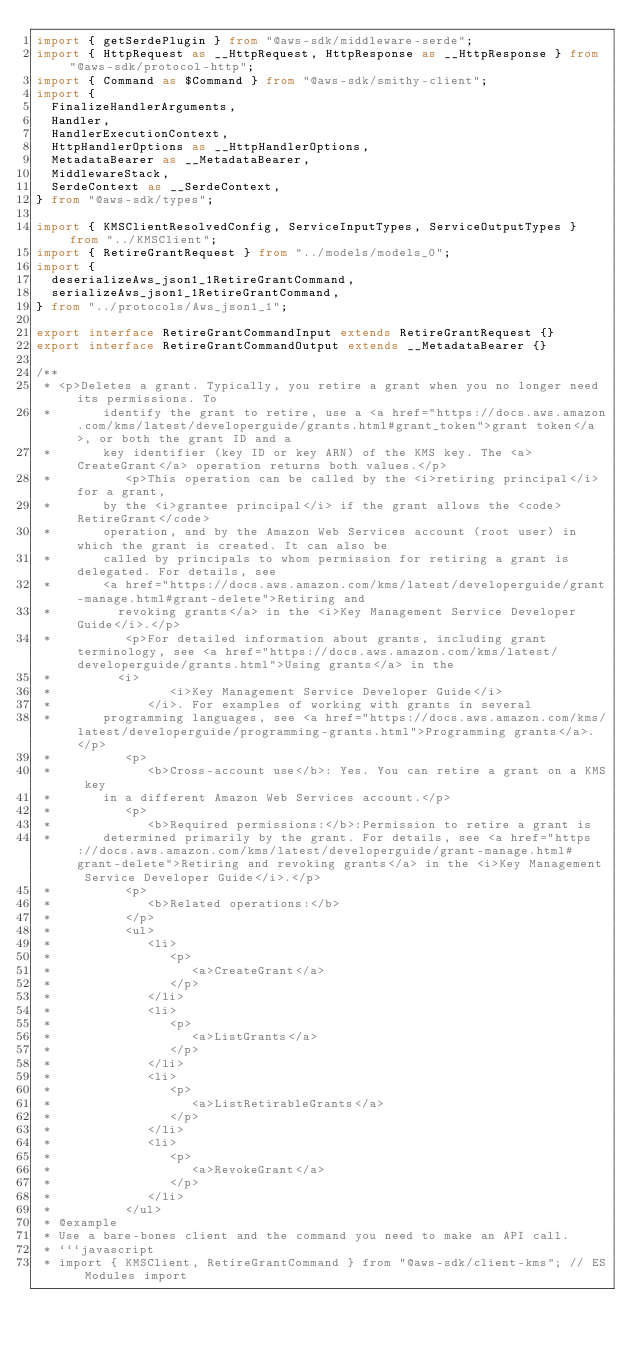Convert code to text. <code><loc_0><loc_0><loc_500><loc_500><_TypeScript_>import { getSerdePlugin } from "@aws-sdk/middleware-serde";
import { HttpRequest as __HttpRequest, HttpResponse as __HttpResponse } from "@aws-sdk/protocol-http";
import { Command as $Command } from "@aws-sdk/smithy-client";
import {
  FinalizeHandlerArguments,
  Handler,
  HandlerExecutionContext,
  HttpHandlerOptions as __HttpHandlerOptions,
  MetadataBearer as __MetadataBearer,
  MiddlewareStack,
  SerdeContext as __SerdeContext,
} from "@aws-sdk/types";

import { KMSClientResolvedConfig, ServiceInputTypes, ServiceOutputTypes } from "../KMSClient";
import { RetireGrantRequest } from "../models/models_0";
import {
  deserializeAws_json1_1RetireGrantCommand,
  serializeAws_json1_1RetireGrantCommand,
} from "../protocols/Aws_json1_1";

export interface RetireGrantCommandInput extends RetireGrantRequest {}
export interface RetireGrantCommandOutput extends __MetadataBearer {}

/**
 * <p>Deletes a grant. Typically, you retire a grant when you no longer need its permissions. To
 *       identify the grant to retire, use a <a href="https://docs.aws.amazon.com/kms/latest/developerguide/grants.html#grant_token">grant token</a>, or both the grant ID and a
 *       key identifier (key ID or key ARN) of the KMS key. The <a>CreateGrant</a> operation returns both values.</p>
 *          <p>This operation can be called by the <i>retiring principal</i> for a grant,
 *       by the <i>grantee principal</i> if the grant allows the <code>RetireGrant</code>
 *       operation, and by the Amazon Web Services account (root user) in which the grant is created. It can also be
 *       called by principals to whom permission for retiring a grant is delegated. For details, see
 *       <a href="https://docs.aws.amazon.com/kms/latest/developerguide/grant-manage.html#grant-delete">Retiring and
 *         revoking grants</a> in the <i>Key Management Service Developer Guide</i>.</p>
 *          <p>For detailed information about grants, including grant terminology, see <a href="https://docs.aws.amazon.com/kms/latest/developerguide/grants.html">Using grants</a> in the
 *         <i>
 *                <i>Key Management Service Developer Guide</i>
 *             </i>. For examples of working with grants in several
 *       programming languages, see <a href="https://docs.aws.amazon.com/kms/latest/developerguide/programming-grants.html">Programming grants</a>. </p>
 *          <p>
 *             <b>Cross-account use</b>: Yes. You can retire a grant on a KMS key
 *       in a different Amazon Web Services account.</p>
 *          <p>
 *             <b>Required permissions:</b>:Permission to retire a grant is
 *       determined primarily by the grant. For details, see <a href="https://docs.aws.amazon.com/kms/latest/developerguide/grant-manage.html#grant-delete">Retiring and revoking grants</a> in the <i>Key Management Service Developer Guide</i>.</p>
 *          <p>
 *             <b>Related operations:</b>
 *          </p>
 *          <ul>
 *             <li>
 *                <p>
 *                   <a>CreateGrant</a>
 *                </p>
 *             </li>
 *             <li>
 *                <p>
 *                   <a>ListGrants</a>
 *                </p>
 *             </li>
 *             <li>
 *                <p>
 *                   <a>ListRetirableGrants</a>
 *                </p>
 *             </li>
 *             <li>
 *                <p>
 *                   <a>RevokeGrant</a>
 *                </p>
 *             </li>
 *          </ul>
 * @example
 * Use a bare-bones client and the command you need to make an API call.
 * ```javascript
 * import { KMSClient, RetireGrantCommand } from "@aws-sdk/client-kms"; // ES Modules import</code> 